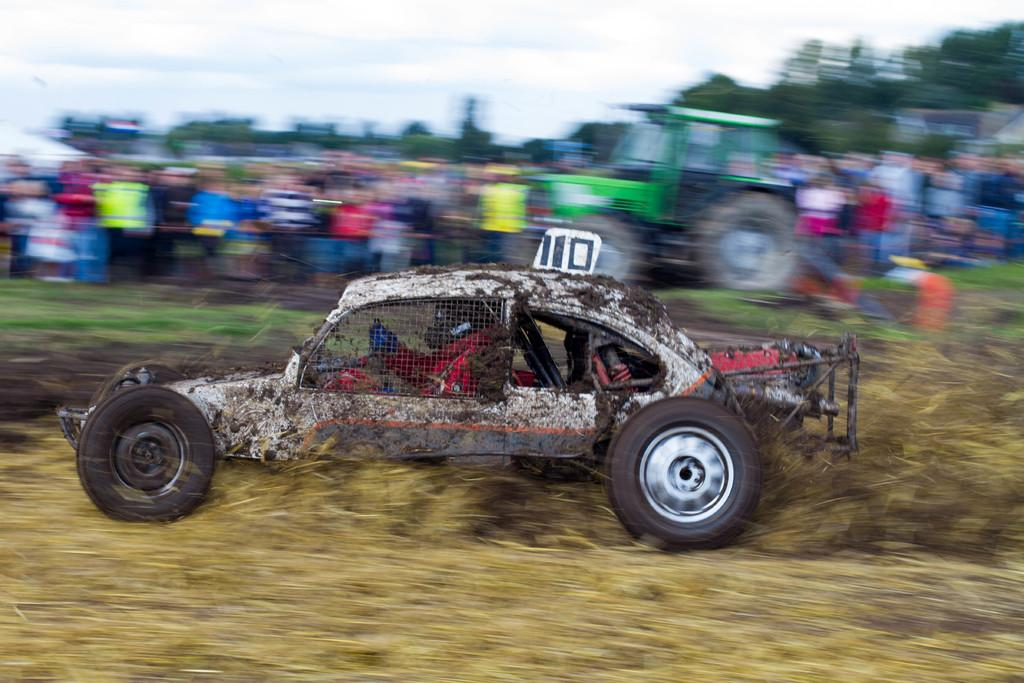What can be seen in the image that is used for transportation? There is a vehicle in the image that is used for transportation. Who is inside the vehicle? A person is sitting in the vehicle. What type of vegetation is present in the image? There is dry grass in the image. What natural element can be seen in the image? There is a tree in the image. What part of the environment is visible in the image? The sky is visible in the image. How would you describe the background of the image? The background of the image is blurred. What type of railway can be seen in the image? There is no railway present in the image. Is the image taken in a snowy environment? No, there is no snow visible in the image. 